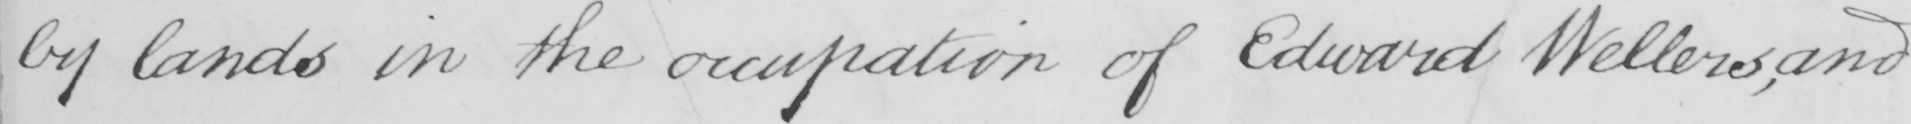What does this handwritten line say? by lands in the occupation of Edward Wellers,and 